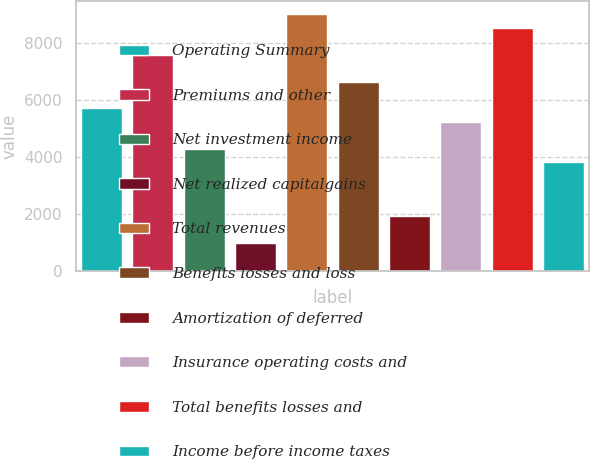Convert chart to OTSL. <chart><loc_0><loc_0><loc_500><loc_500><bar_chart><fcel>Operating Summary<fcel>Premiums and other<fcel>Net investment income<fcel>Net realized capitalgains<fcel>Total revenues<fcel>Benefits losses and loss<fcel>Amortization of deferred<fcel>Insurance operating costs and<fcel>Total benefits losses and<fcel>Income before income taxes<nl><fcel>5698.94<fcel>7590.82<fcel>4280.03<fcel>969.24<fcel>9009.73<fcel>6644.88<fcel>1915.18<fcel>5225.97<fcel>8536.76<fcel>3807.06<nl></chart> 